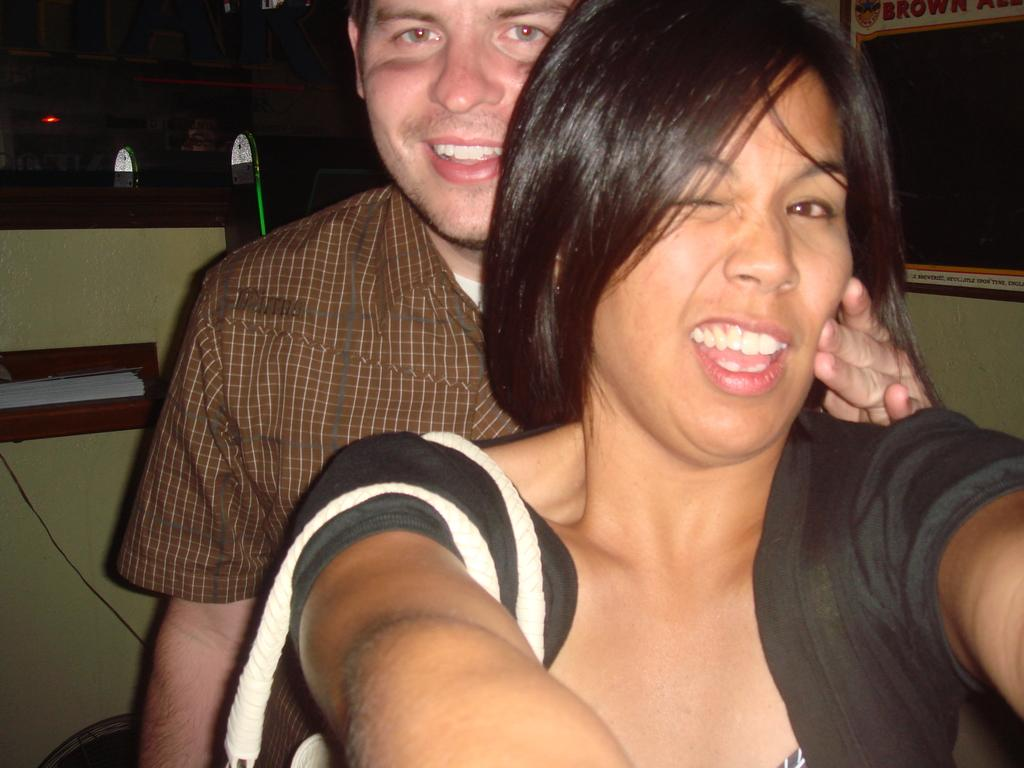How many persons are in the image? There are persons in the image, but the exact number is not specified. What are the persons wearing in the image? The persons are wearing clothes in the image. What can be seen in the background of the image? There is a wall in the background of the image. What type of care can be seen being provided to the men in the image? There is no indication in the image that any care is being provided to men, as the facts provided do not mention men or any care being given. 